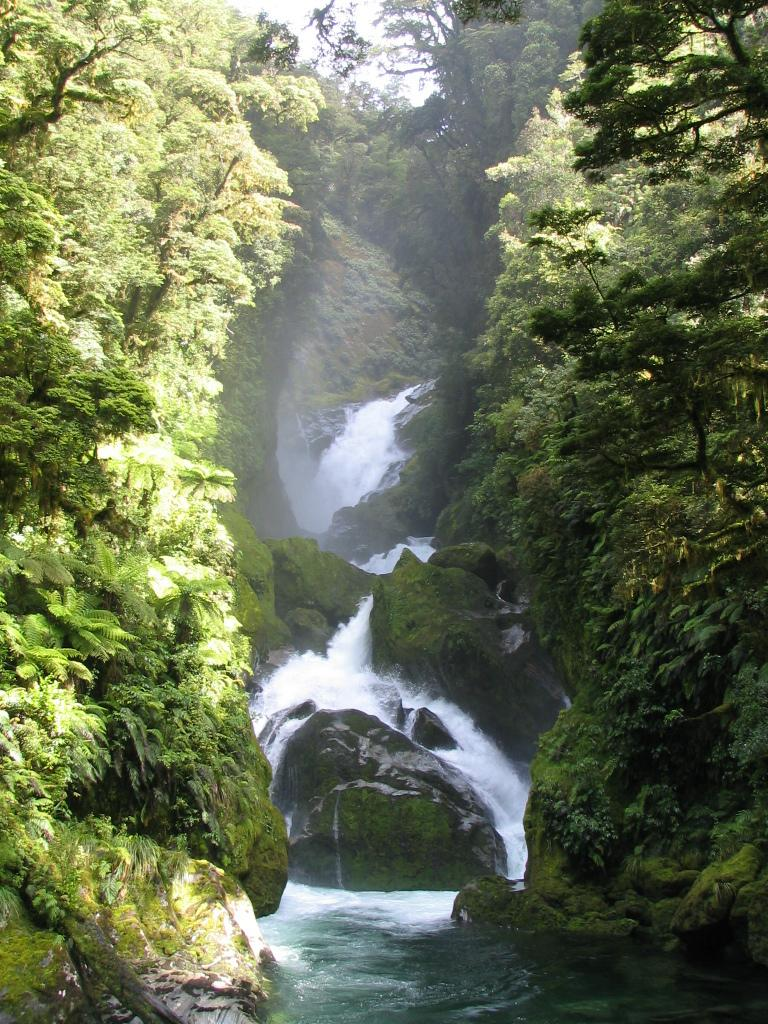What type of natural growth can be seen in the image? There are trees and plants in the image. What other natural elements are present in the image? There is algae, rocks, and a waterfall in the image. Can you describe the waterfall in the image? There is a waterfall in the image. What shape is the crayon in the image? There is no crayon present in the image. How does the spark from the waterfall light up the image? There is no spark in the image; it is a natural waterfall. 